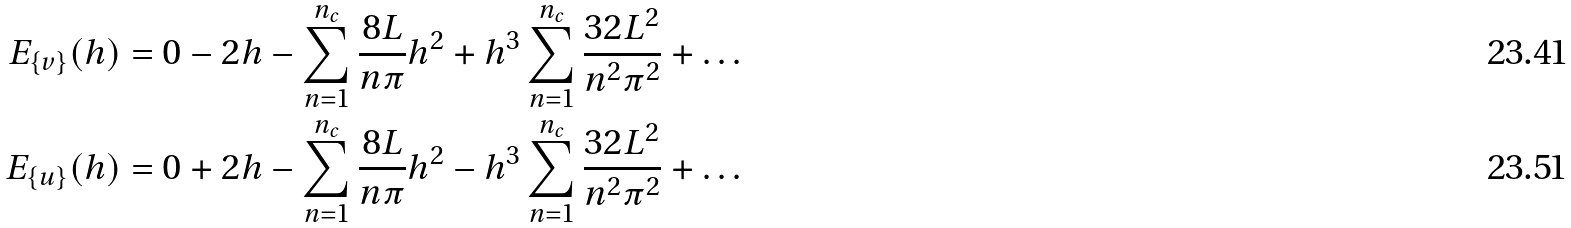Convert formula to latex. <formula><loc_0><loc_0><loc_500><loc_500>E _ { \{ v \} } ( h ) & = 0 - 2 h - \sum _ { n = 1 } ^ { n _ { c } } \frac { 8 L } { n \pi } h ^ { 2 } + h ^ { 3 } \sum _ { n = 1 } ^ { n _ { c } } \frac { 3 2 L ^ { 2 } } { n ^ { 2 } \pi ^ { 2 } } + \dots \\ E _ { \{ u \} } ( h ) & = 0 + 2 h - \sum _ { n = 1 } ^ { n _ { c } } \frac { 8 L } { n \pi } h ^ { 2 } - h ^ { 3 } \sum _ { n = 1 } ^ { n _ { c } } \frac { 3 2 L ^ { 2 } } { n ^ { 2 } \pi ^ { 2 } } + \dots</formula> 